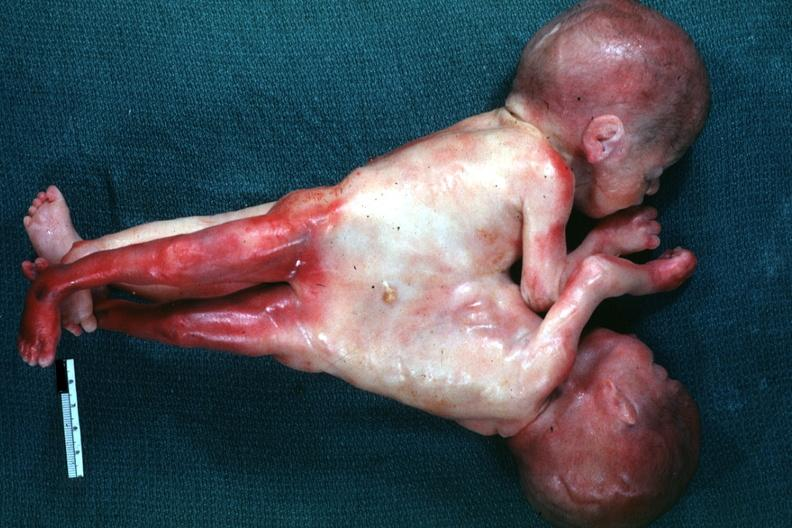what is lateral view joined?
Answer the question using a single word or phrase. At chest and abdomen 